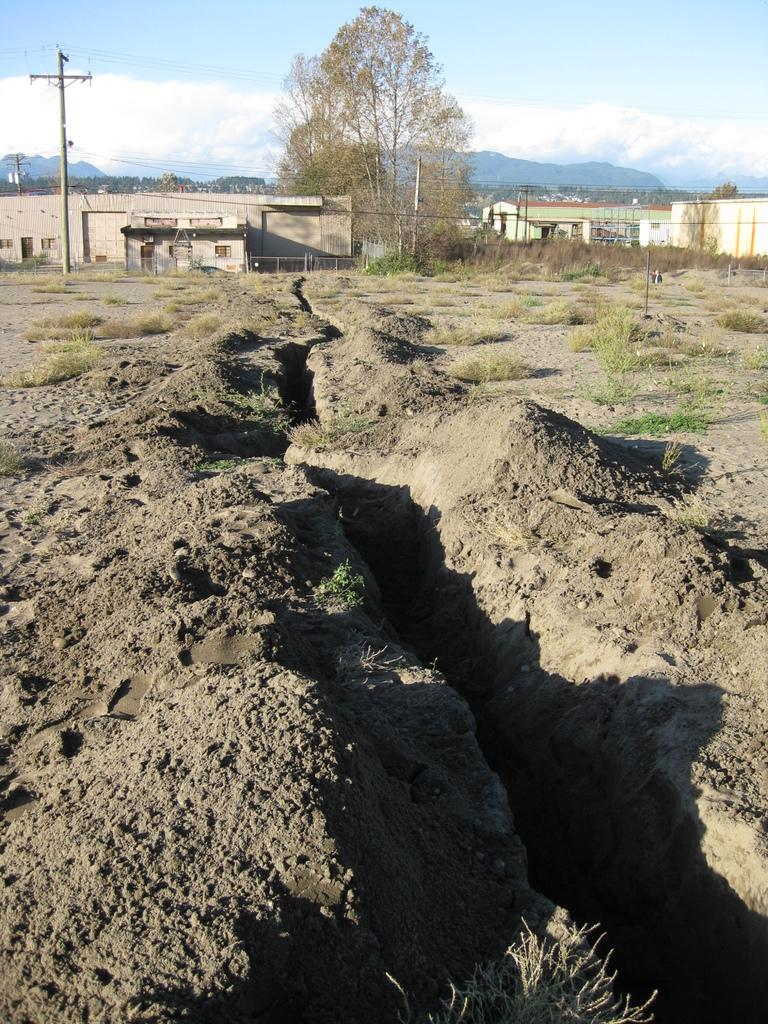What type of structures can be seen in the image? There are buildings in the image. What type of vegetation is present in the image? There are plants and trees in the image. What type of man-made objects can be seen in the image? There are poles and cables in the image. What type of natural features can be seen in the image? There are hills in the image. What is visible in the background of the image? The sky is visible in the background of the image. Can you tell me how many hooks are hanging from the trees in the image? There are no hooks hanging from the trees in the image; only poles, cables, and trees are present. What is the relationship between the people in the image? There are no people present in the image, so it is not possible to determine their relationships. 